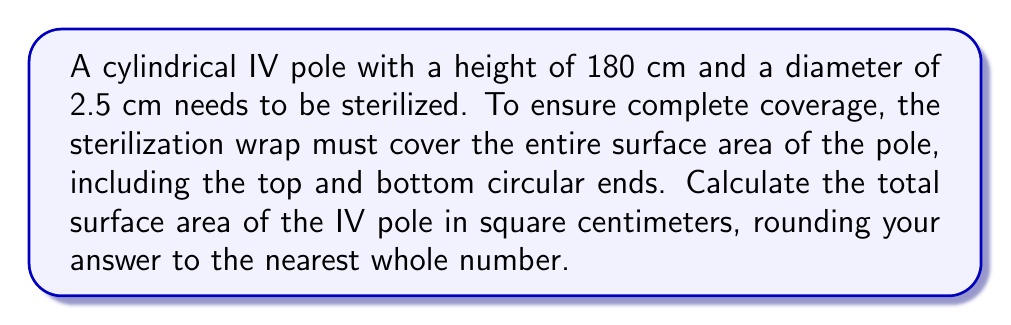Help me with this question. To calculate the surface area of the cylindrical IV pole, we need to consider three parts:
1. The lateral surface area (curved surface)
2. The top circular surface
3. The bottom circular surface

Step 1: Calculate the lateral surface area
The formula for the lateral surface area of a cylinder is $A_l = 2\pi rh$, where $r$ is the radius and $h$ is the height.

Radius: $r = \frac{\text{diameter}}{2} = \frac{2.5}{2} = 1.25$ cm
Height: $h = 180$ cm

$A_l = 2\pi(1.25)(180) = 450\pi$ cm²

Step 2: Calculate the area of one circular end
The formula for the area of a circle is $A_c = \pi r^2$

$A_c = \pi(1.25)^2 = 1.5625\pi$ cm²

Step 3: Calculate the total surface area
Total surface area = Lateral surface area + 2 × Area of circular end
$$A_{\text{total}} = A_l + 2A_c = 450\pi + 2(1.5625\pi) = 453.125\pi \text{ cm}^2$$

Step 4: Convert to a numerical value and round
$$A_{\text{total}} = 453.125\pi \approx 1423.30 \text{ cm}^2$$

Rounding to the nearest whole number: 1423 cm²
Answer: 1423 cm² 